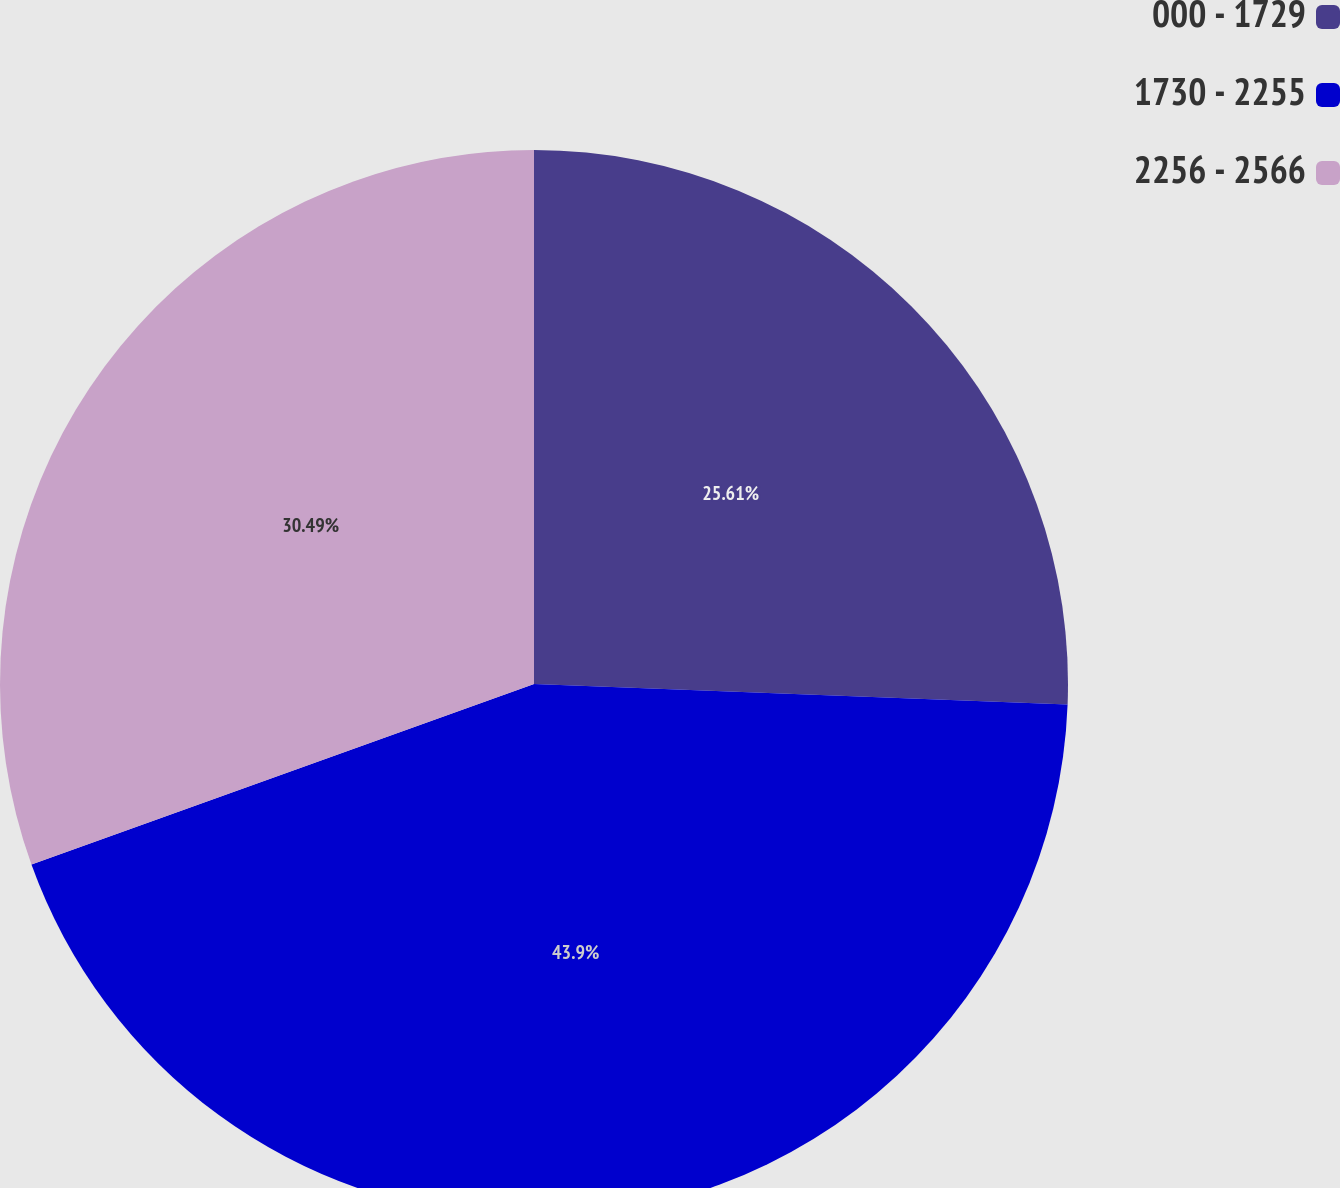<chart> <loc_0><loc_0><loc_500><loc_500><pie_chart><fcel>000 - 1729<fcel>1730 - 2255<fcel>2256 - 2566<nl><fcel>25.61%<fcel>43.9%<fcel>30.49%<nl></chart> 